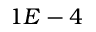Convert formula to latex. <formula><loc_0><loc_0><loc_500><loc_500>1 E - 4</formula> 